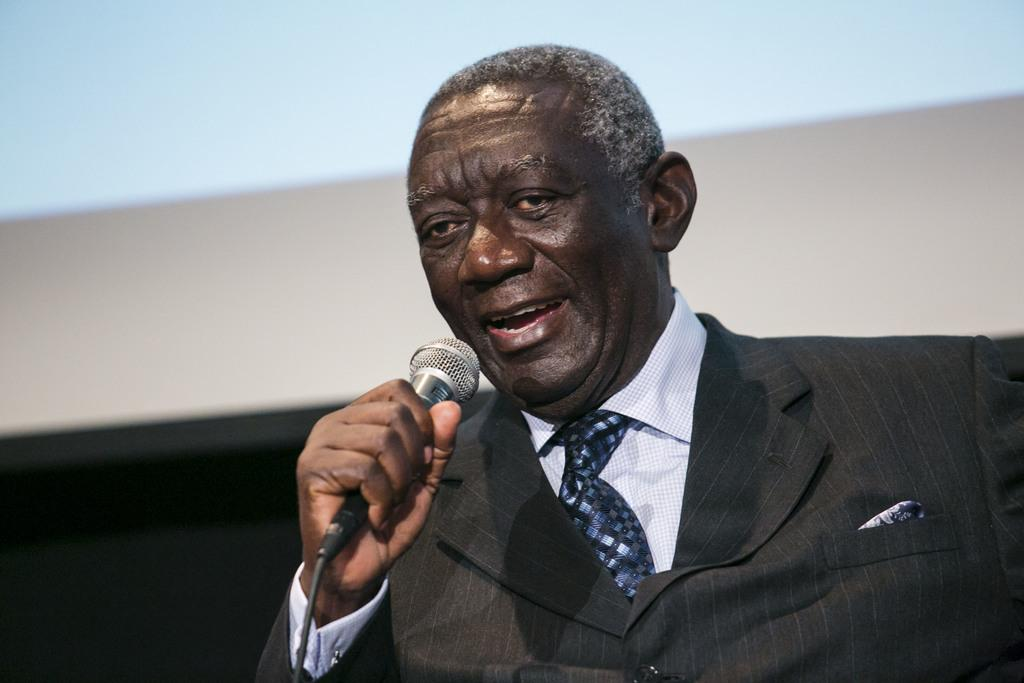Who is the main subject in the image? There is a person in the image. What is the person wearing? The person is wearing a black suit. What is the person doing in the image? The person is speaking in front of a microphone. What type of soda is being served at the event in the image? There is no event or soda present in the image; it only shows a person wearing a black suit and speaking in front of a microphone. 